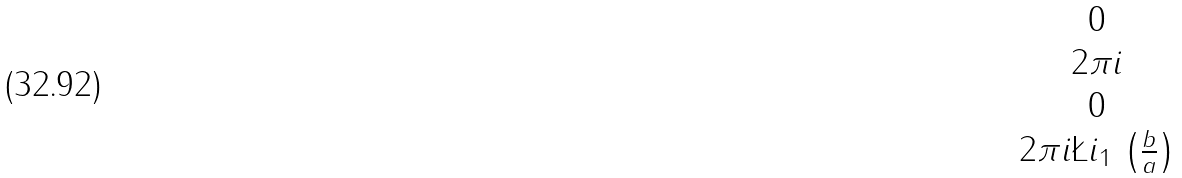Convert formula to latex. <formula><loc_0><loc_0><loc_500><loc_500>\begin{matrix} 0 \\ 2 \pi i \\ 0 \\ 2 \pi i \L i _ { 1 } \, \left ( \frac { b } { a } \right ) \end{matrix}</formula> 